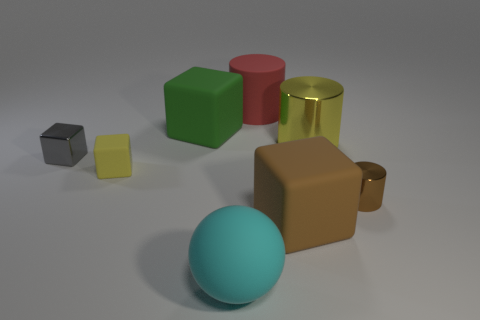The block on the left side of the yellow matte object is what color?
Your response must be concise. Gray. There is a big yellow shiny cylinder in front of the big green rubber block; is there a large brown rubber block to the right of it?
Keep it short and to the point. No. Are there fewer large green objects than gray metal cylinders?
Ensure brevity in your answer.  No. What is the material of the yellow thing behind the gray metallic cube to the left of the yellow metal object?
Give a very brief answer. Metal. Is the size of the gray metal cube the same as the yellow block?
Ensure brevity in your answer.  Yes. How many objects are either large balls or metallic things?
Give a very brief answer. 4. What is the size of the rubber block that is both in front of the big metallic thing and left of the large matte ball?
Provide a succinct answer. Small. Are there fewer cyan balls that are behind the small rubber cube than tiny red rubber balls?
Offer a terse response. No. There is a cyan object that is made of the same material as the small yellow block; what is its shape?
Your answer should be very brief. Sphere. There is a large brown rubber thing that is in front of the brown metal object; is it the same shape as the metallic object that is to the left of the red cylinder?
Offer a terse response. Yes. 